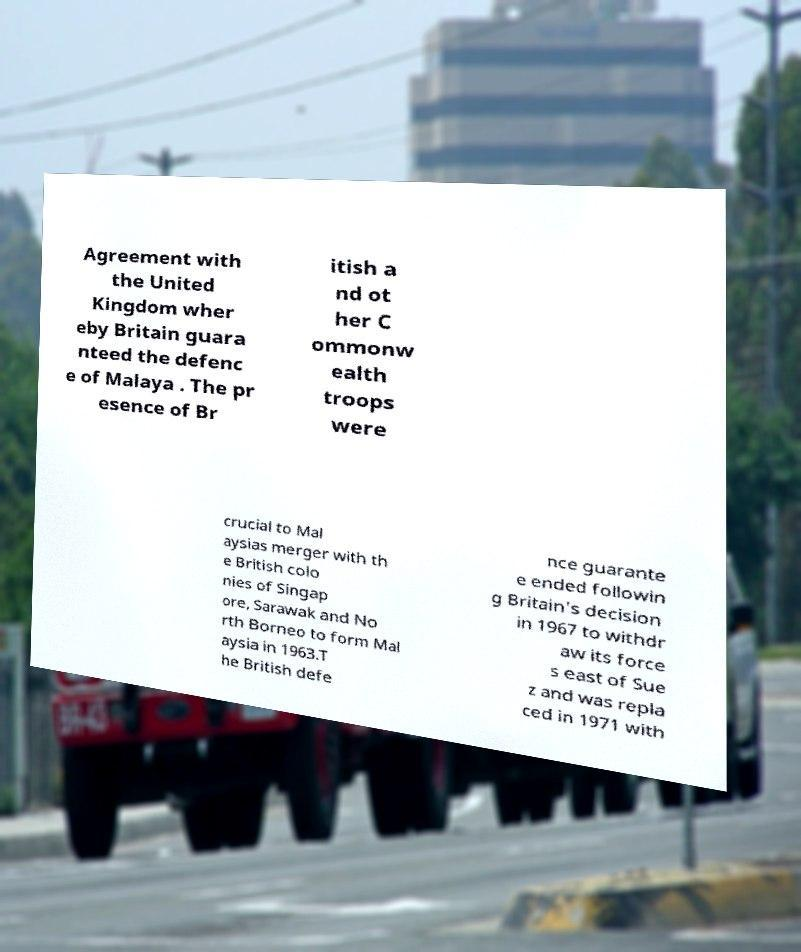Can you accurately transcribe the text from the provided image for me? Agreement with the United Kingdom wher eby Britain guara nteed the defenc e of Malaya . The pr esence of Br itish a nd ot her C ommonw ealth troops were crucial to Mal aysias merger with th e British colo nies of Singap ore, Sarawak and No rth Borneo to form Mal aysia in 1963.T he British defe nce guarante e ended followin g Britain's decision in 1967 to withdr aw its force s east of Sue z and was repla ced in 1971 with 